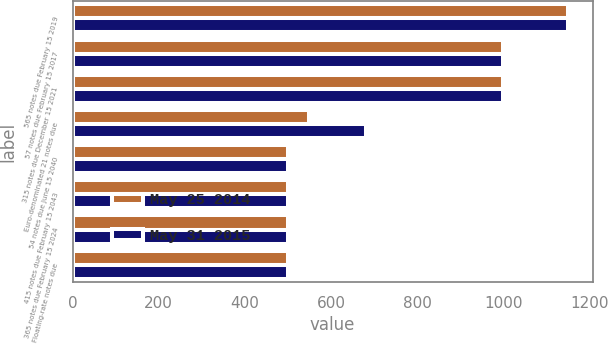<chart> <loc_0><loc_0><loc_500><loc_500><stacked_bar_chart><ecel><fcel>565 notes due February 15 2019<fcel>57 notes due February 15 2017<fcel>315 notes due December 15 2021<fcel>Euro-denominated 21 notes due<fcel>54 notes due June 15 2040<fcel>415 notes due February 15 2043<fcel>365 notes due February 15 2024<fcel>Floating-rate notes due<nl><fcel>May 25 2014<fcel>1150<fcel>1000<fcel>1000<fcel>549.4<fcel>500<fcel>500<fcel>500<fcel>500<nl><fcel>May 31 2015<fcel>1150<fcel>1000<fcel>1000<fcel>681.5<fcel>500<fcel>500<fcel>500<fcel>500<nl></chart> 